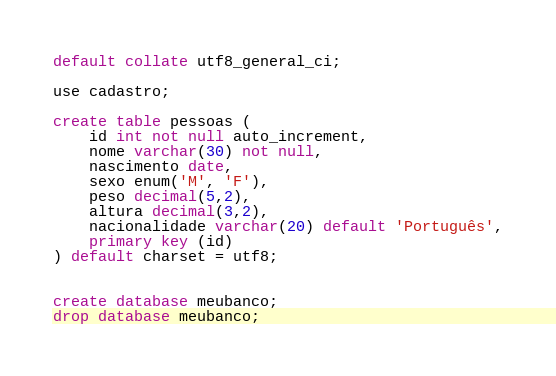Convert code to text. <code><loc_0><loc_0><loc_500><loc_500><_SQL_>default collate utf8_general_ci;

use cadastro;

create table pessoas (
    id int not null auto_increment,
    nome varchar(30) not null,
    nascimento date,
    sexo enum('M', 'F'),
    peso decimal(5,2),
    altura decimal(3,2),
    nacionalidade varchar(20) default 'Português',
    primary key (id)
) default charset = utf8;


create database meubanco;
drop database meubanco;
</code> 